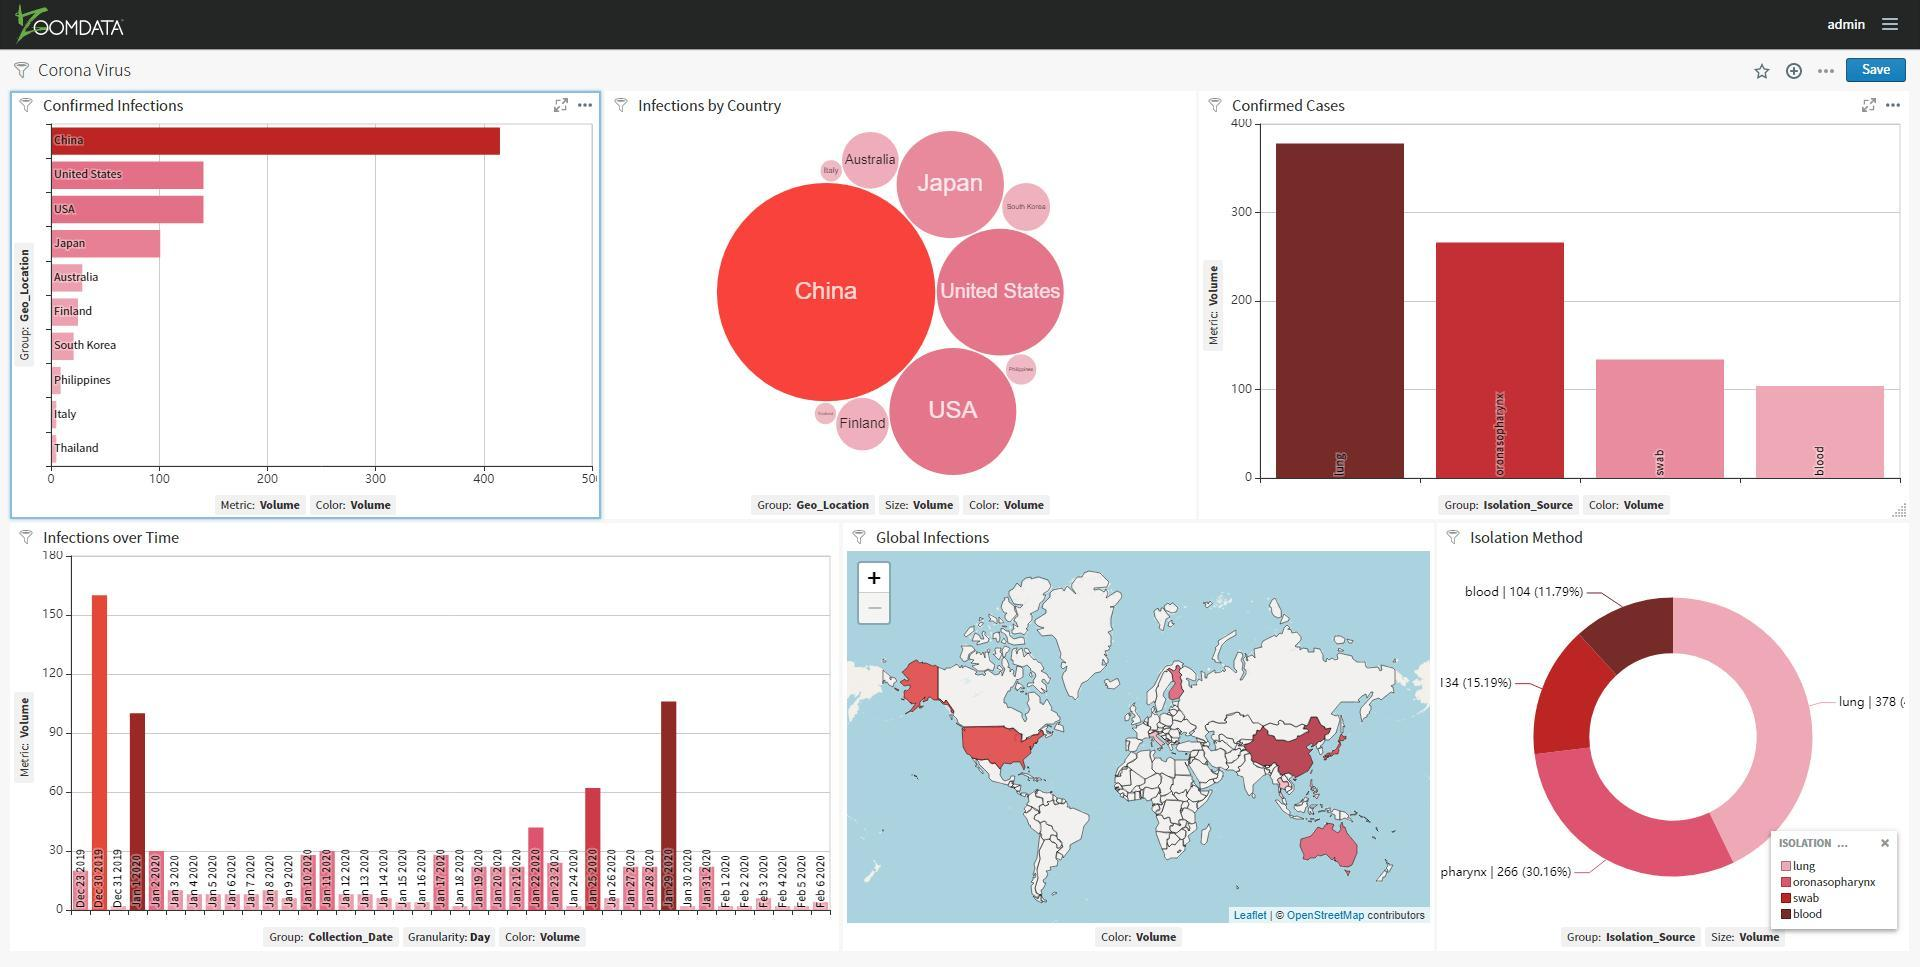How many countries have confirmed infections less than 100?
Answer the question with a short phrase. 6 How many countries have confirmed infections greater than or equal to 100? 4 Which country has the highest number of infections? China 